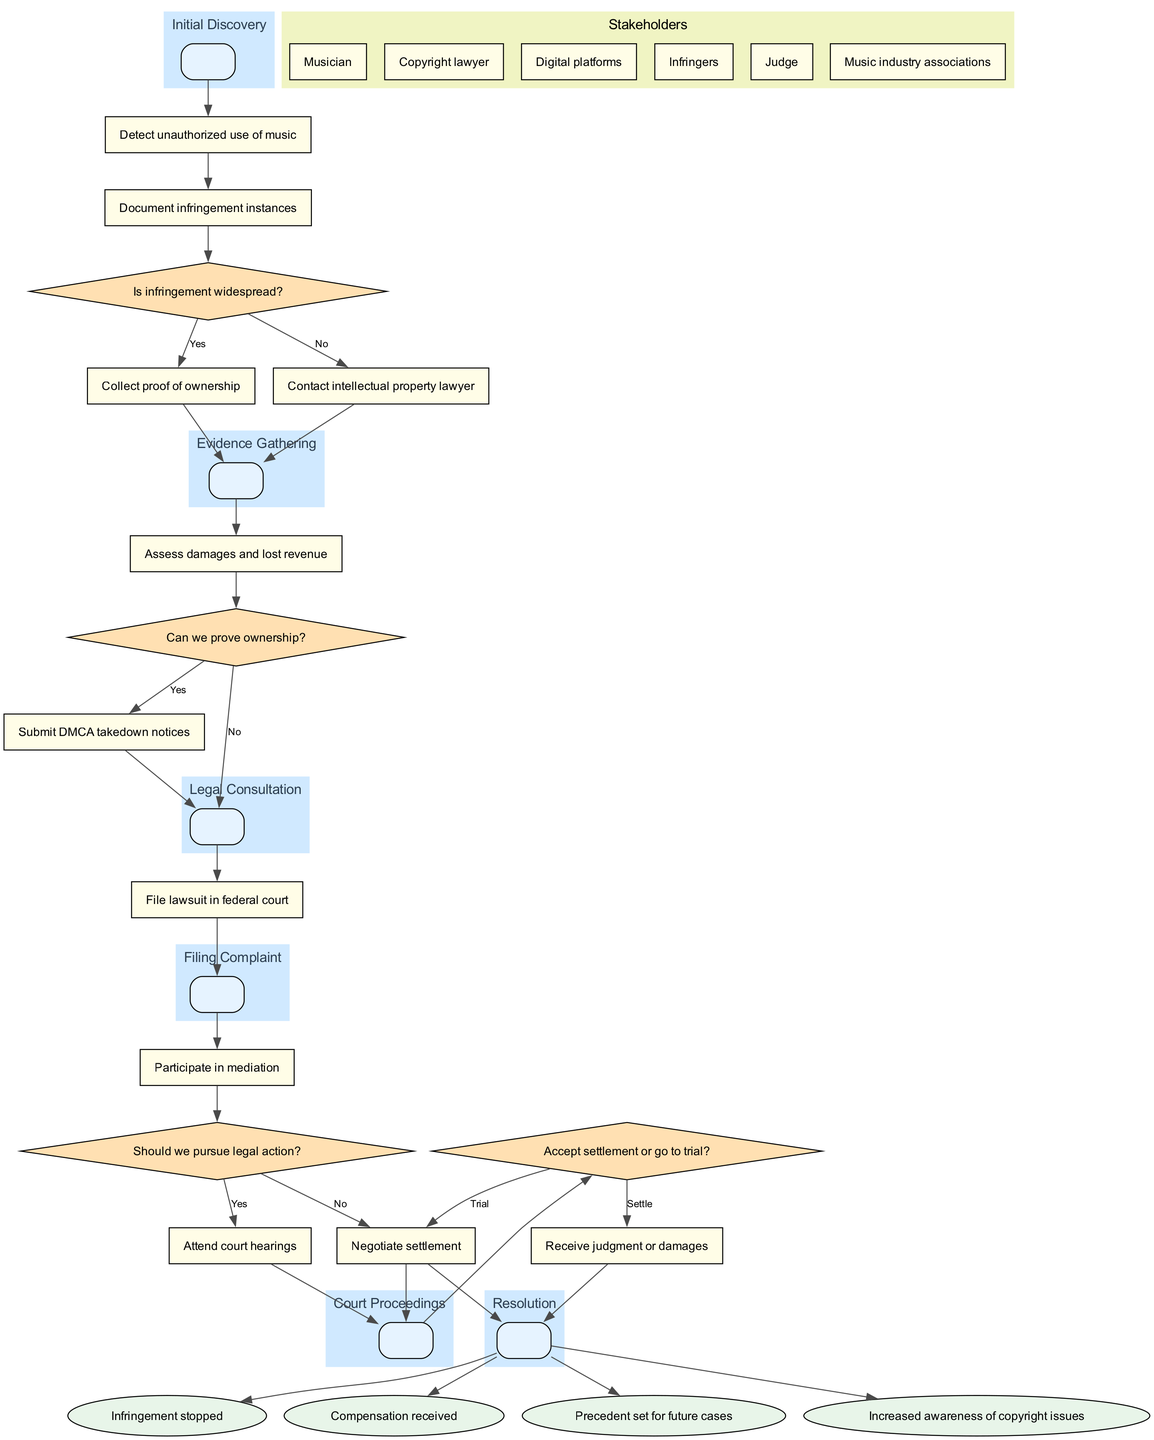What is the first stage in the pathway? The first stage listed in the diagram is "Initial Discovery," which is mentioned at the top of the diagram.
Answer: Initial Discovery How many actions are included in the diagram? By counting the actions in the list, there are a total of 11 actions represented.
Answer: 11 What decision follows the action "Document infringement instances"? The decision that comes after "Document infringement instances" is "Can we prove ownership?" so the flow moves from action to this decision node.
Answer: Can we prove ownership? What is the outcome if a lawsuit is filed in federal court? The diagram indicates that after completing court proceedings, one of the outcomes is "Compensation received," which follows from a successful legal action.
Answer: Compensation received Which stakeholder is involved after the "Legal Consultation" stage? After the "Legal Consultation" stage, the diagram indicates actions are taken, and the next stage is indicative of involvement from the "Copyright lawyer" as the legal professional consulted.
Answer: Copyright lawyer What happens if infringement is found to be widespread? If infringement is found to be widespread, the flow indicates that evidence gathering continues based on the ensuing connection labeled "Yes," which leads to further actions.
Answer: Evidence gathering continues Which decision requires evaluation of settlement options? The decision that evaluates whether to accept a settlement or go to trial is labeled "Accept settlement or go to trial?" and follows the "Court Proceedings" stage.
Answer: Accept settlement or go to trial? In how many instances can infringement instances be documented? The diagram illustrates that "Document infringement instances" can occur multiple times; however, it doesn't specify an exact number, so we deduce that it can vary for each case.
Answer: Varies 